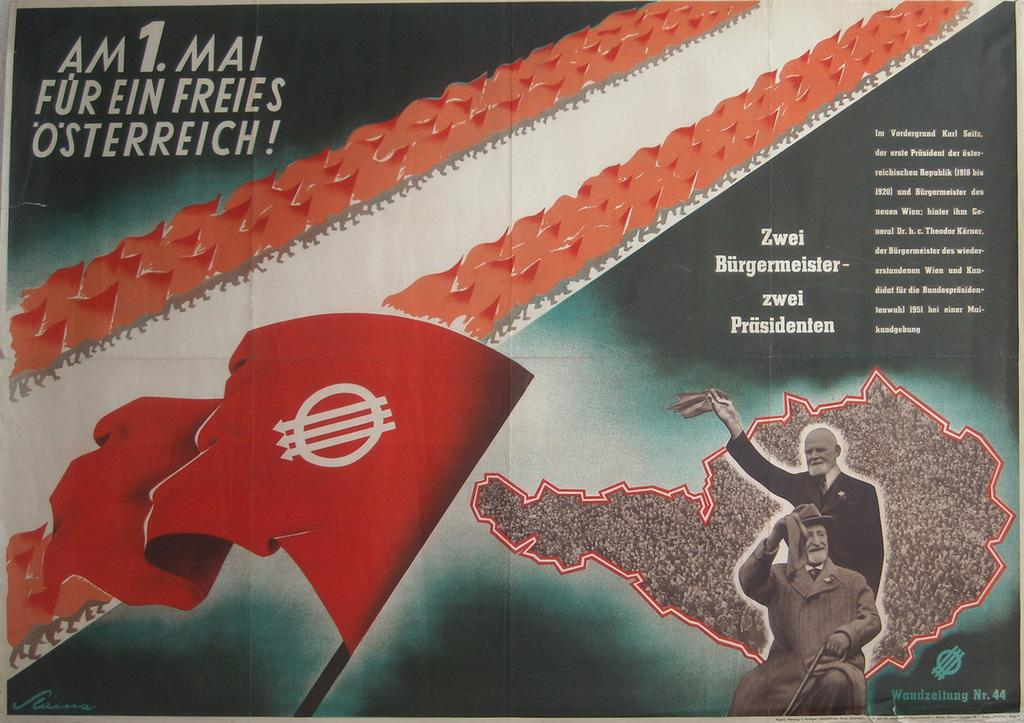<image>
Summarize the visual content of the image. A red flag with a circle and three arrows with the word osterreich above it. 